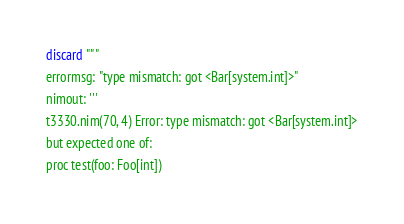Convert code to text. <code><loc_0><loc_0><loc_500><loc_500><_Nim_>discard """
errormsg: "type mismatch: got <Bar[system.int]>"
nimout: '''
t3330.nim(70, 4) Error: type mismatch: got <Bar[system.int]>
but expected one of:
proc test(foo: Foo[int])</code> 